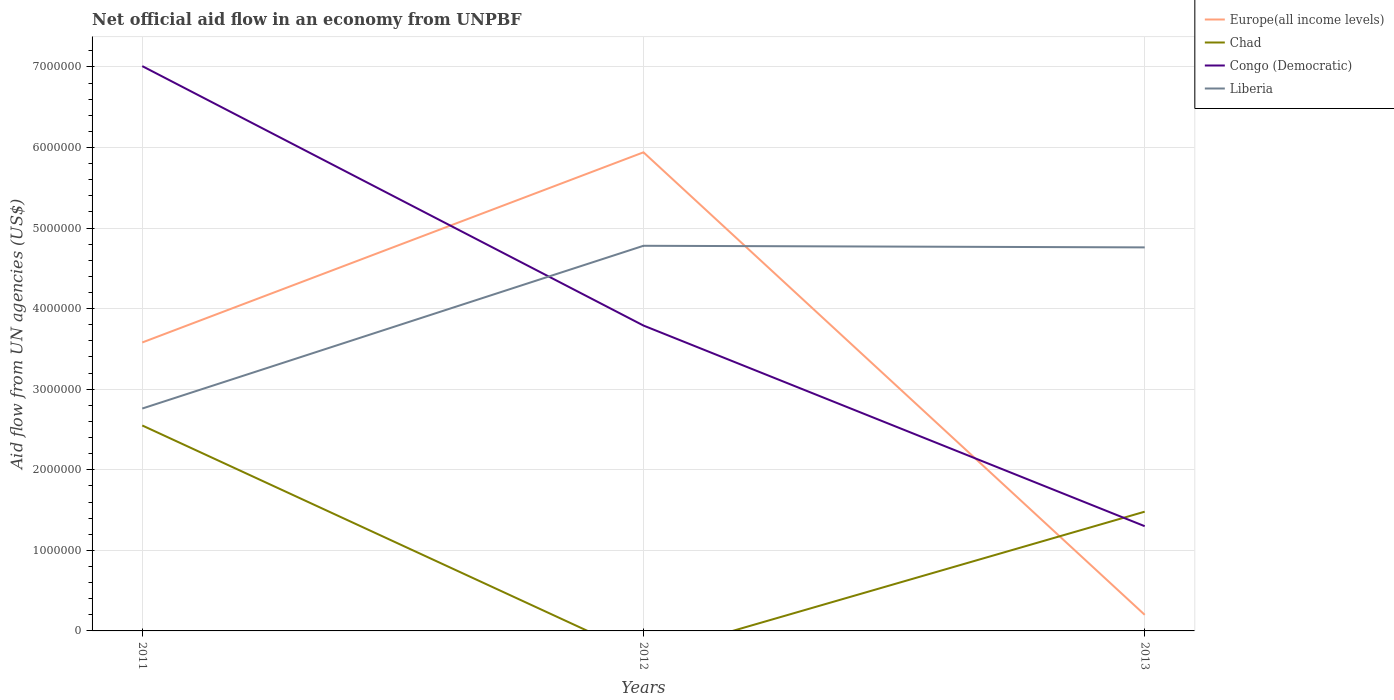Does the line corresponding to Chad intersect with the line corresponding to Liberia?
Your answer should be very brief. No. Across all years, what is the maximum net official aid flow in Europe(all income levels)?
Your answer should be compact. 2.00e+05. What is the total net official aid flow in Europe(all income levels) in the graph?
Offer a terse response. 3.38e+06. What is the difference between the highest and the second highest net official aid flow in Europe(all income levels)?
Provide a short and direct response. 5.74e+06. How many years are there in the graph?
Your answer should be compact. 3. Are the values on the major ticks of Y-axis written in scientific E-notation?
Your answer should be very brief. No. Does the graph contain grids?
Give a very brief answer. Yes. How are the legend labels stacked?
Provide a short and direct response. Vertical. What is the title of the graph?
Provide a short and direct response. Net official aid flow in an economy from UNPBF. Does "Argentina" appear as one of the legend labels in the graph?
Ensure brevity in your answer.  No. What is the label or title of the X-axis?
Offer a very short reply. Years. What is the label or title of the Y-axis?
Provide a short and direct response. Aid flow from UN agencies (US$). What is the Aid flow from UN agencies (US$) in Europe(all income levels) in 2011?
Keep it short and to the point. 3.58e+06. What is the Aid flow from UN agencies (US$) in Chad in 2011?
Your response must be concise. 2.55e+06. What is the Aid flow from UN agencies (US$) of Congo (Democratic) in 2011?
Provide a succinct answer. 7.01e+06. What is the Aid flow from UN agencies (US$) in Liberia in 2011?
Offer a very short reply. 2.76e+06. What is the Aid flow from UN agencies (US$) of Europe(all income levels) in 2012?
Provide a succinct answer. 5.94e+06. What is the Aid flow from UN agencies (US$) in Congo (Democratic) in 2012?
Provide a short and direct response. 3.79e+06. What is the Aid flow from UN agencies (US$) of Liberia in 2012?
Provide a succinct answer. 4.78e+06. What is the Aid flow from UN agencies (US$) in Europe(all income levels) in 2013?
Your answer should be very brief. 2.00e+05. What is the Aid flow from UN agencies (US$) in Chad in 2013?
Your answer should be compact. 1.48e+06. What is the Aid flow from UN agencies (US$) in Congo (Democratic) in 2013?
Give a very brief answer. 1.30e+06. What is the Aid flow from UN agencies (US$) in Liberia in 2013?
Give a very brief answer. 4.76e+06. Across all years, what is the maximum Aid flow from UN agencies (US$) of Europe(all income levels)?
Keep it short and to the point. 5.94e+06. Across all years, what is the maximum Aid flow from UN agencies (US$) of Chad?
Offer a very short reply. 2.55e+06. Across all years, what is the maximum Aid flow from UN agencies (US$) in Congo (Democratic)?
Give a very brief answer. 7.01e+06. Across all years, what is the maximum Aid flow from UN agencies (US$) of Liberia?
Offer a terse response. 4.78e+06. Across all years, what is the minimum Aid flow from UN agencies (US$) of Europe(all income levels)?
Your response must be concise. 2.00e+05. Across all years, what is the minimum Aid flow from UN agencies (US$) of Chad?
Offer a terse response. 0. Across all years, what is the minimum Aid flow from UN agencies (US$) of Congo (Democratic)?
Provide a succinct answer. 1.30e+06. Across all years, what is the minimum Aid flow from UN agencies (US$) of Liberia?
Offer a terse response. 2.76e+06. What is the total Aid flow from UN agencies (US$) of Europe(all income levels) in the graph?
Offer a terse response. 9.72e+06. What is the total Aid flow from UN agencies (US$) in Chad in the graph?
Keep it short and to the point. 4.03e+06. What is the total Aid flow from UN agencies (US$) of Congo (Democratic) in the graph?
Provide a succinct answer. 1.21e+07. What is the total Aid flow from UN agencies (US$) of Liberia in the graph?
Give a very brief answer. 1.23e+07. What is the difference between the Aid flow from UN agencies (US$) of Europe(all income levels) in 2011 and that in 2012?
Your answer should be compact. -2.36e+06. What is the difference between the Aid flow from UN agencies (US$) of Congo (Democratic) in 2011 and that in 2012?
Provide a succinct answer. 3.22e+06. What is the difference between the Aid flow from UN agencies (US$) in Liberia in 2011 and that in 2012?
Keep it short and to the point. -2.02e+06. What is the difference between the Aid flow from UN agencies (US$) in Europe(all income levels) in 2011 and that in 2013?
Your response must be concise. 3.38e+06. What is the difference between the Aid flow from UN agencies (US$) of Chad in 2011 and that in 2013?
Ensure brevity in your answer.  1.07e+06. What is the difference between the Aid flow from UN agencies (US$) of Congo (Democratic) in 2011 and that in 2013?
Make the answer very short. 5.71e+06. What is the difference between the Aid flow from UN agencies (US$) of Liberia in 2011 and that in 2013?
Your answer should be compact. -2.00e+06. What is the difference between the Aid flow from UN agencies (US$) of Europe(all income levels) in 2012 and that in 2013?
Provide a succinct answer. 5.74e+06. What is the difference between the Aid flow from UN agencies (US$) of Congo (Democratic) in 2012 and that in 2013?
Make the answer very short. 2.49e+06. What is the difference between the Aid flow from UN agencies (US$) of Liberia in 2012 and that in 2013?
Provide a succinct answer. 2.00e+04. What is the difference between the Aid flow from UN agencies (US$) of Europe(all income levels) in 2011 and the Aid flow from UN agencies (US$) of Liberia in 2012?
Give a very brief answer. -1.20e+06. What is the difference between the Aid flow from UN agencies (US$) in Chad in 2011 and the Aid flow from UN agencies (US$) in Congo (Democratic) in 2012?
Ensure brevity in your answer.  -1.24e+06. What is the difference between the Aid flow from UN agencies (US$) in Chad in 2011 and the Aid flow from UN agencies (US$) in Liberia in 2012?
Give a very brief answer. -2.23e+06. What is the difference between the Aid flow from UN agencies (US$) of Congo (Democratic) in 2011 and the Aid flow from UN agencies (US$) of Liberia in 2012?
Your answer should be very brief. 2.23e+06. What is the difference between the Aid flow from UN agencies (US$) in Europe(all income levels) in 2011 and the Aid flow from UN agencies (US$) in Chad in 2013?
Your answer should be very brief. 2.10e+06. What is the difference between the Aid flow from UN agencies (US$) of Europe(all income levels) in 2011 and the Aid flow from UN agencies (US$) of Congo (Democratic) in 2013?
Ensure brevity in your answer.  2.28e+06. What is the difference between the Aid flow from UN agencies (US$) in Europe(all income levels) in 2011 and the Aid flow from UN agencies (US$) in Liberia in 2013?
Your response must be concise. -1.18e+06. What is the difference between the Aid flow from UN agencies (US$) of Chad in 2011 and the Aid flow from UN agencies (US$) of Congo (Democratic) in 2013?
Your answer should be compact. 1.25e+06. What is the difference between the Aid flow from UN agencies (US$) in Chad in 2011 and the Aid flow from UN agencies (US$) in Liberia in 2013?
Your response must be concise. -2.21e+06. What is the difference between the Aid flow from UN agencies (US$) in Congo (Democratic) in 2011 and the Aid flow from UN agencies (US$) in Liberia in 2013?
Offer a terse response. 2.25e+06. What is the difference between the Aid flow from UN agencies (US$) of Europe(all income levels) in 2012 and the Aid flow from UN agencies (US$) of Chad in 2013?
Keep it short and to the point. 4.46e+06. What is the difference between the Aid flow from UN agencies (US$) in Europe(all income levels) in 2012 and the Aid flow from UN agencies (US$) in Congo (Democratic) in 2013?
Ensure brevity in your answer.  4.64e+06. What is the difference between the Aid flow from UN agencies (US$) in Europe(all income levels) in 2012 and the Aid flow from UN agencies (US$) in Liberia in 2013?
Offer a terse response. 1.18e+06. What is the difference between the Aid flow from UN agencies (US$) in Congo (Democratic) in 2012 and the Aid flow from UN agencies (US$) in Liberia in 2013?
Make the answer very short. -9.70e+05. What is the average Aid flow from UN agencies (US$) in Europe(all income levels) per year?
Ensure brevity in your answer.  3.24e+06. What is the average Aid flow from UN agencies (US$) of Chad per year?
Keep it short and to the point. 1.34e+06. What is the average Aid flow from UN agencies (US$) in Congo (Democratic) per year?
Provide a succinct answer. 4.03e+06. What is the average Aid flow from UN agencies (US$) of Liberia per year?
Your answer should be compact. 4.10e+06. In the year 2011, what is the difference between the Aid flow from UN agencies (US$) in Europe(all income levels) and Aid flow from UN agencies (US$) in Chad?
Offer a terse response. 1.03e+06. In the year 2011, what is the difference between the Aid flow from UN agencies (US$) of Europe(all income levels) and Aid flow from UN agencies (US$) of Congo (Democratic)?
Provide a short and direct response. -3.43e+06. In the year 2011, what is the difference between the Aid flow from UN agencies (US$) of Europe(all income levels) and Aid flow from UN agencies (US$) of Liberia?
Offer a very short reply. 8.20e+05. In the year 2011, what is the difference between the Aid flow from UN agencies (US$) of Chad and Aid flow from UN agencies (US$) of Congo (Democratic)?
Offer a very short reply. -4.46e+06. In the year 2011, what is the difference between the Aid flow from UN agencies (US$) of Chad and Aid flow from UN agencies (US$) of Liberia?
Your response must be concise. -2.10e+05. In the year 2011, what is the difference between the Aid flow from UN agencies (US$) in Congo (Democratic) and Aid flow from UN agencies (US$) in Liberia?
Your response must be concise. 4.25e+06. In the year 2012, what is the difference between the Aid flow from UN agencies (US$) in Europe(all income levels) and Aid flow from UN agencies (US$) in Congo (Democratic)?
Make the answer very short. 2.15e+06. In the year 2012, what is the difference between the Aid flow from UN agencies (US$) of Europe(all income levels) and Aid flow from UN agencies (US$) of Liberia?
Give a very brief answer. 1.16e+06. In the year 2012, what is the difference between the Aid flow from UN agencies (US$) of Congo (Democratic) and Aid flow from UN agencies (US$) of Liberia?
Keep it short and to the point. -9.90e+05. In the year 2013, what is the difference between the Aid flow from UN agencies (US$) of Europe(all income levels) and Aid flow from UN agencies (US$) of Chad?
Your answer should be compact. -1.28e+06. In the year 2013, what is the difference between the Aid flow from UN agencies (US$) in Europe(all income levels) and Aid flow from UN agencies (US$) in Congo (Democratic)?
Provide a succinct answer. -1.10e+06. In the year 2013, what is the difference between the Aid flow from UN agencies (US$) of Europe(all income levels) and Aid flow from UN agencies (US$) of Liberia?
Provide a short and direct response. -4.56e+06. In the year 2013, what is the difference between the Aid flow from UN agencies (US$) of Chad and Aid flow from UN agencies (US$) of Liberia?
Offer a very short reply. -3.28e+06. In the year 2013, what is the difference between the Aid flow from UN agencies (US$) in Congo (Democratic) and Aid flow from UN agencies (US$) in Liberia?
Make the answer very short. -3.46e+06. What is the ratio of the Aid flow from UN agencies (US$) in Europe(all income levels) in 2011 to that in 2012?
Ensure brevity in your answer.  0.6. What is the ratio of the Aid flow from UN agencies (US$) in Congo (Democratic) in 2011 to that in 2012?
Ensure brevity in your answer.  1.85. What is the ratio of the Aid flow from UN agencies (US$) in Liberia in 2011 to that in 2012?
Give a very brief answer. 0.58. What is the ratio of the Aid flow from UN agencies (US$) in Chad in 2011 to that in 2013?
Your answer should be compact. 1.72. What is the ratio of the Aid flow from UN agencies (US$) in Congo (Democratic) in 2011 to that in 2013?
Ensure brevity in your answer.  5.39. What is the ratio of the Aid flow from UN agencies (US$) of Liberia in 2011 to that in 2013?
Your answer should be compact. 0.58. What is the ratio of the Aid flow from UN agencies (US$) of Europe(all income levels) in 2012 to that in 2013?
Provide a succinct answer. 29.7. What is the ratio of the Aid flow from UN agencies (US$) of Congo (Democratic) in 2012 to that in 2013?
Ensure brevity in your answer.  2.92. What is the difference between the highest and the second highest Aid flow from UN agencies (US$) in Europe(all income levels)?
Your response must be concise. 2.36e+06. What is the difference between the highest and the second highest Aid flow from UN agencies (US$) of Congo (Democratic)?
Give a very brief answer. 3.22e+06. What is the difference between the highest and the lowest Aid flow from UN agencies (US$) of Europe(all income levels)?
Make the answer very short. 5.74e+06. What is the difference between the highest and the lowest Aid flow from UN agencies (US$) of Chad?
Provide a succinct answer. 2.55e+06. What is the difference between the highest and the lowest Aid flow from UN agencies (US$) of Congo (Democratic)?
Offer a very short reply. 5.71e+06. What is the difference between the highest and the lowest Aid flow from UN agencies (US$) in Liberia?
Your response must be concise. 2.02e+06. 